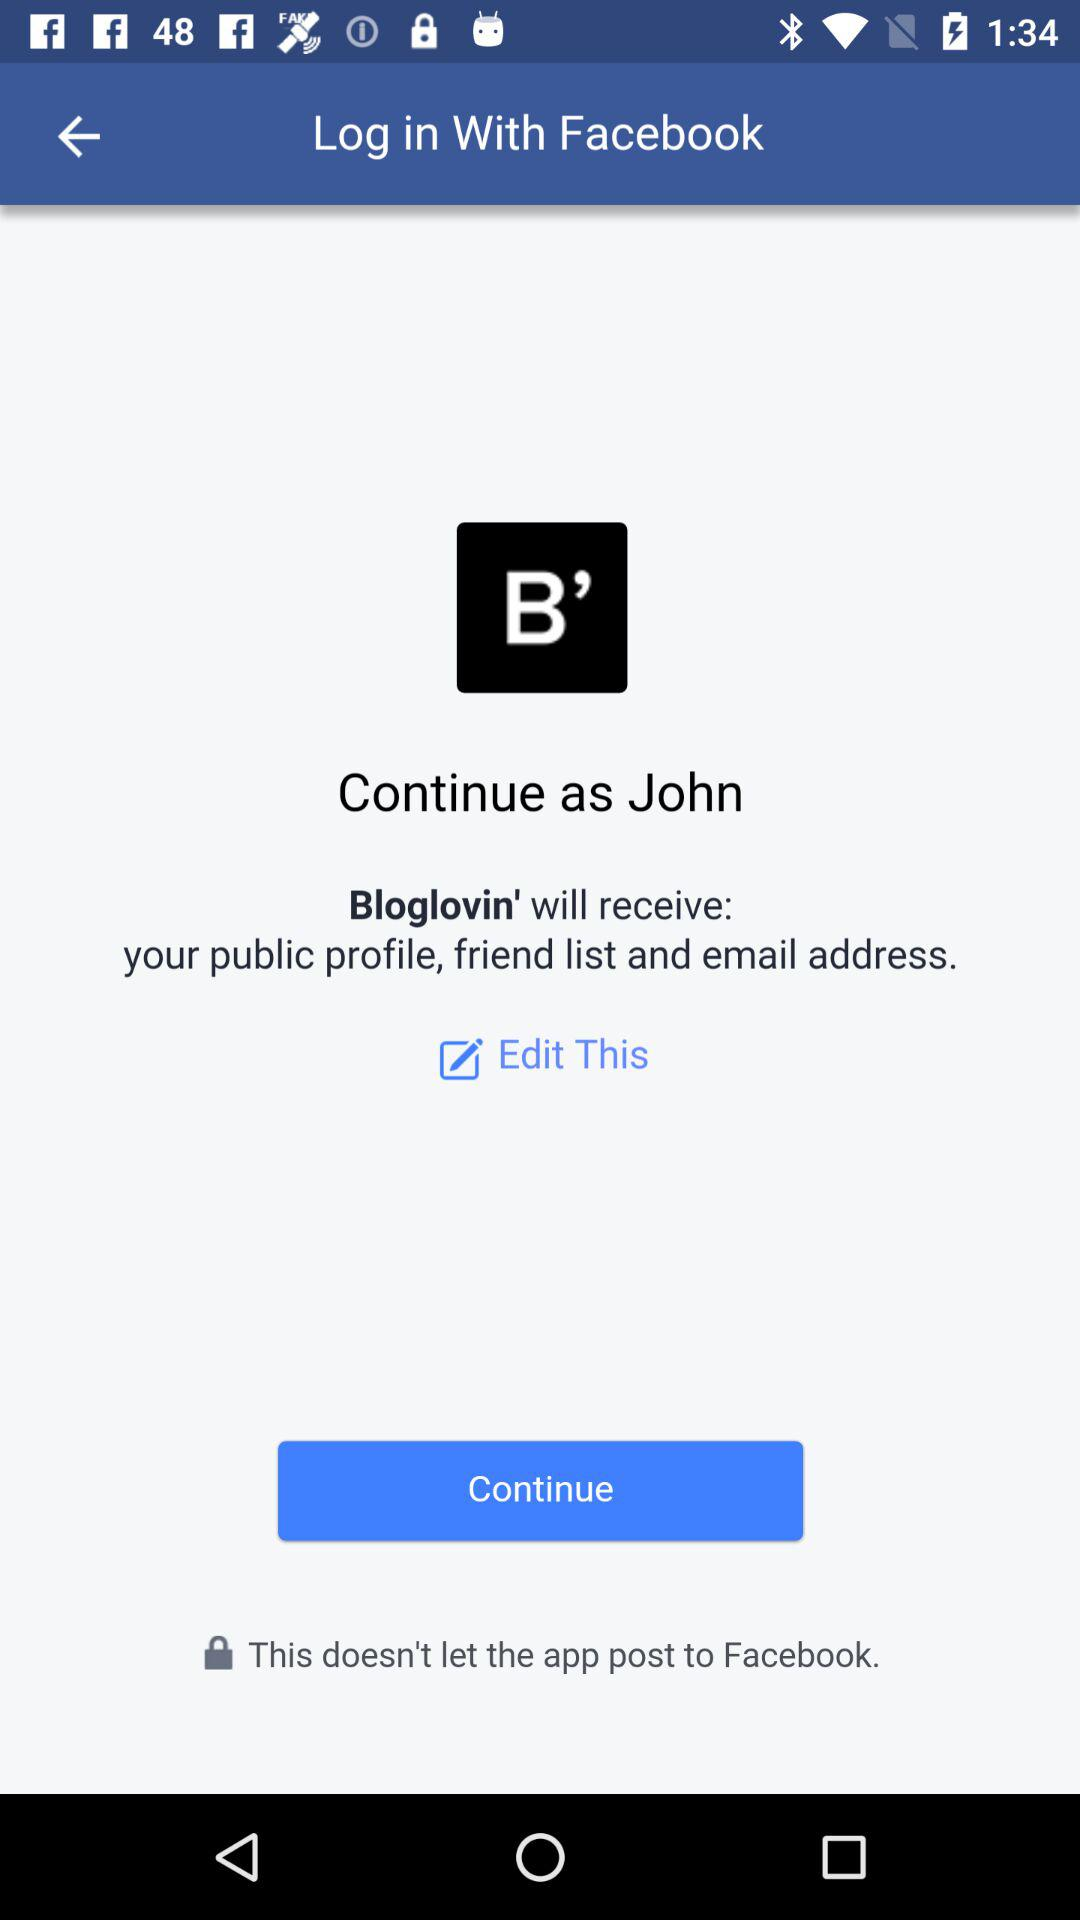What application will receive the public profile, friend list and email address? The application that will receive the public profile, friend list and email address is "Bloglovin'". 